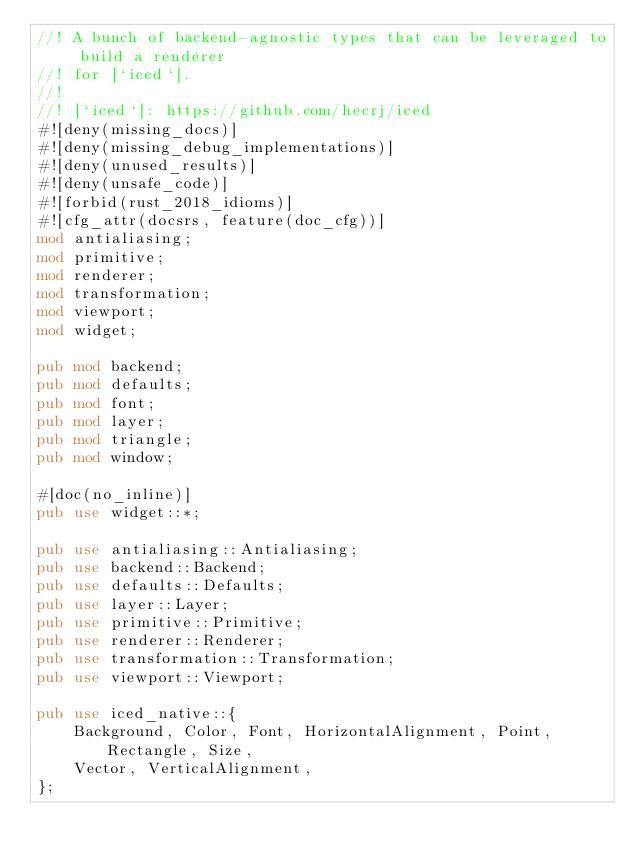Convert code to text. <code><loc_0><loc_0><loc_500><loc_500><_Rust_>//! A bunch of backend-agnostic types that can be leveraged to build a renderer
//! for [`iced`].
//!
//! [`iced`]: https://github.com/hecrj/iced
#![deny(missing_docs)]
#![deny(missing_debug_implementations)]
#![deny(unused_results)]
#![deny(unsafe_code)]
#![forbid(rust_2018_idioms)]
#![cfg_attr(docsrs, feature(doc_cfg))]
mod antialiasing;
mod primitive;
mod renderer;
mod transformation;
mod viewport;
mod widget;

pub mod backend;
pub mod defaults;
pub mod font;
pub mod layer;
pub mod triangle;
pub mod window;

#[doc(no_inline)]
pub use widget::*;

pub use antialiasing::Antialiasing;
pub use backend::Backend;
pub use defaults::Defaults;
pub use layer::Layer;
pub use primitive::Primitive;
pub use renderer::Renderer;
pub use transformation::Transformation;
pub use viewport::Viewport;

pub use iced_native::{
    Background, Color, Font, HorizontalAlignment, Point, Rectangle, Size,
    Vector, VerticalAlignment,
};
</code> 